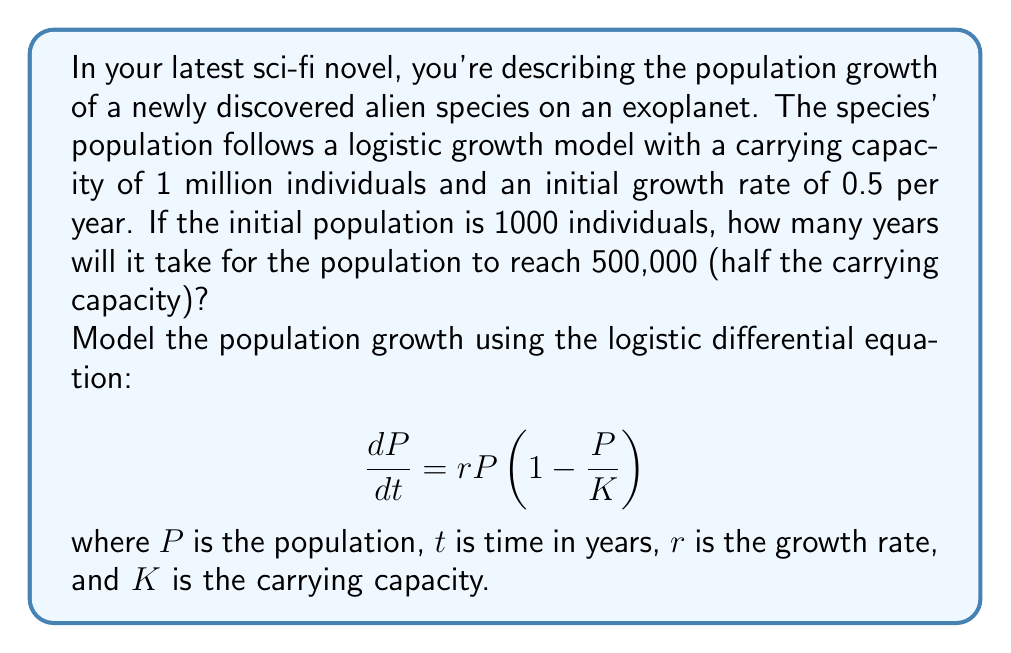Solve this math problem. To solve this problem, we'll use the logistic differential equation and its solution:

1) The logistic differential equation is:
   $$\frac{dP}{dt} = rP(1-\frac{P}{K})$$

2) The solution to this equation is:
   $$P(t) = \frac{K}{1 + (\frac{K}{P_0} - 1)e^{-rt}}$$
   where $P_0$ is the initial population.

3) Given information:
   $K = 1,000,000$ (carrying capacity)
   $r = 0.5$ per year (growth rate)
   $P_0 = 1,000$ (initial population)
   $P(t) = 500,000$ (target population, half of carrying capacity)

4) Substitute these values into the solution equation:
   $$500,000 = \frac{1,000,000}{1 + (\frac{1,000,000}{1,000} - 1)e^{-0.5t}}$$

5) Simplify:
   $$\frac{1}{2} = \frac{1}{1 + 999e^{-0.5t}}$$

6) Solve for $t$:
   $$1 + 999e^{-0.5t} = 2$$
   $$999e^{-0.5t} = 1$$
   $$e^{-0.5t} = \frac{1}{999}$$
   $$-0.5t = \ln(\frac{1}{999}) = -\ln(999)$$
   $$t = \frac{2\ln(999)}{0.5} = 4\ln(999) \approx 27.63$$

Therefore, it will take approximately 27.63 years for the alien population to reach 500,000 individuals.
Answer: $t \approx 27.63$ years 